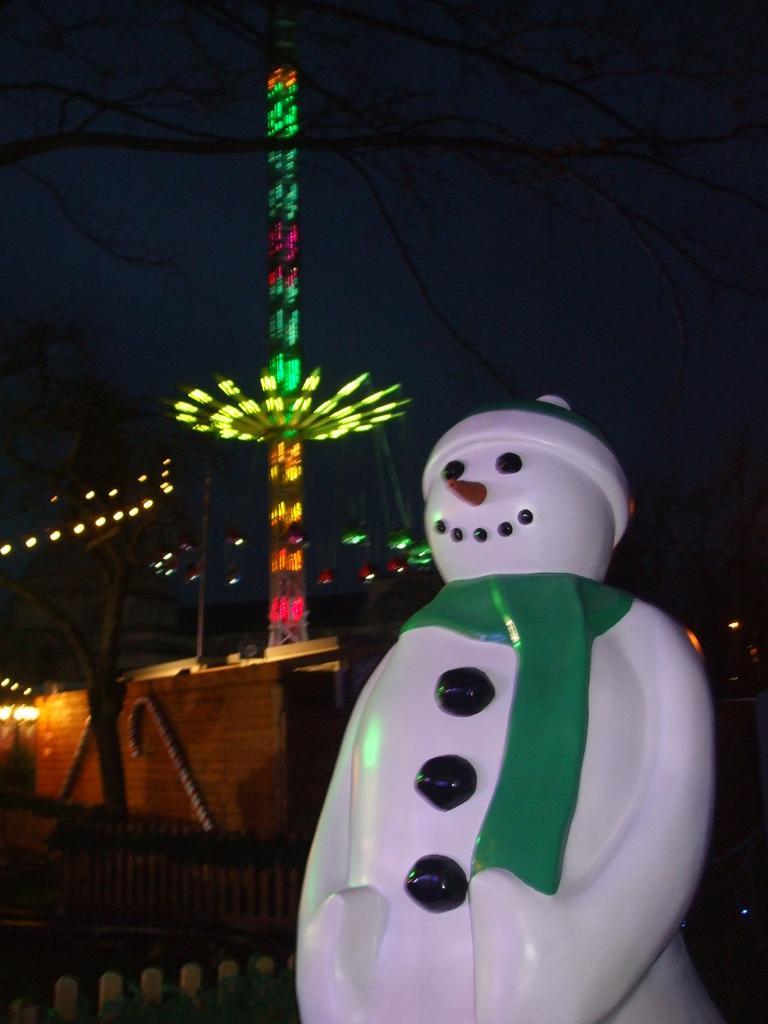Can you describe this image briefly? On the right side it is a doll in white color. In the middle it is a circular wheel with the lights. At the top it is the sky. 